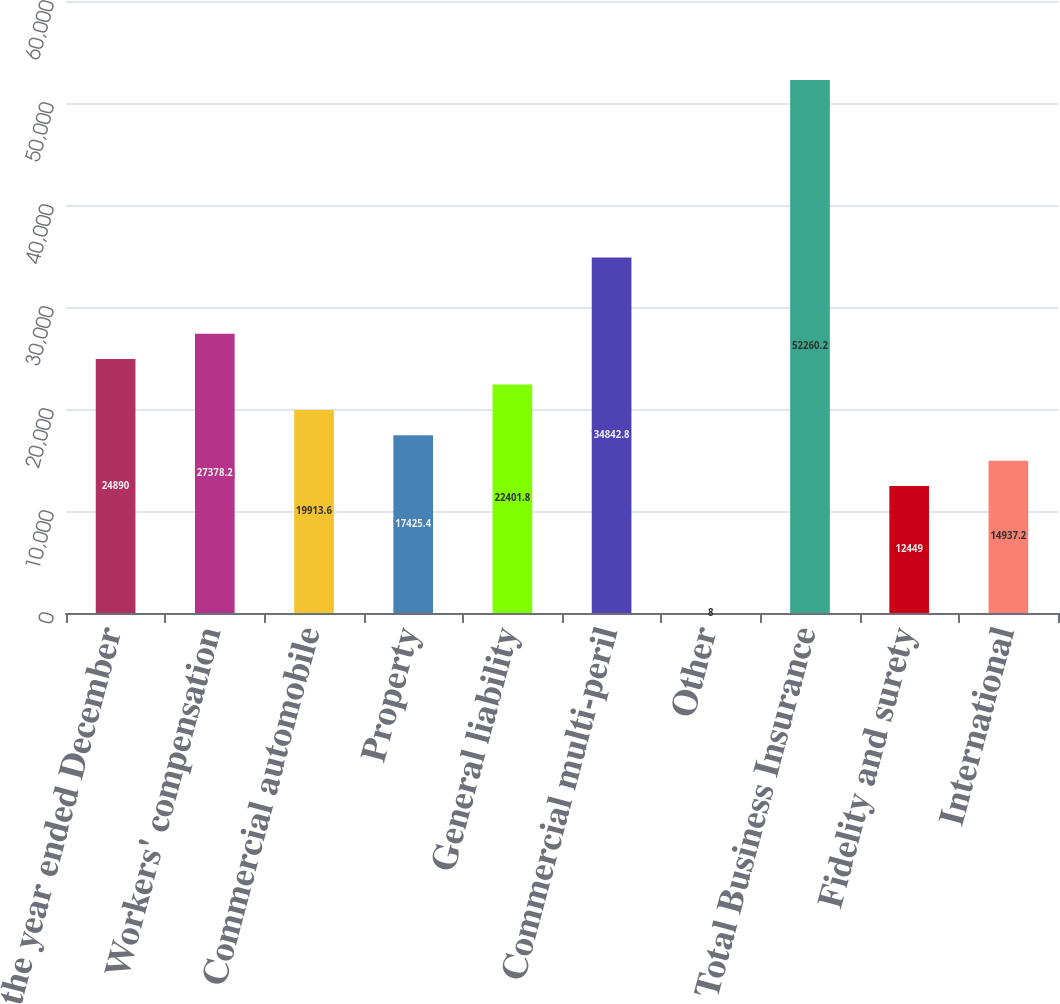<chart> <loc_0><loc_0><loc_500><loc_500><bar_chart><fcel>(for the year ended December<fcel>Workers' compensation<fcel>Commercial automobile<fcel>Property<fcel>General liability<fcel>Commercial multi-peril<fcel>Other<fcel>Total Business Insurance<fcel>Fidelity and surety<fcel>International<nl><fcel>24890<fcel>27378.2<fcel>19913.6<fcel>17425.4<fcel>22401.8<fcel>34842.8<fcel>8<fcel>52260.2<fcel>12449<fcel>14937.2<nl></chart> 